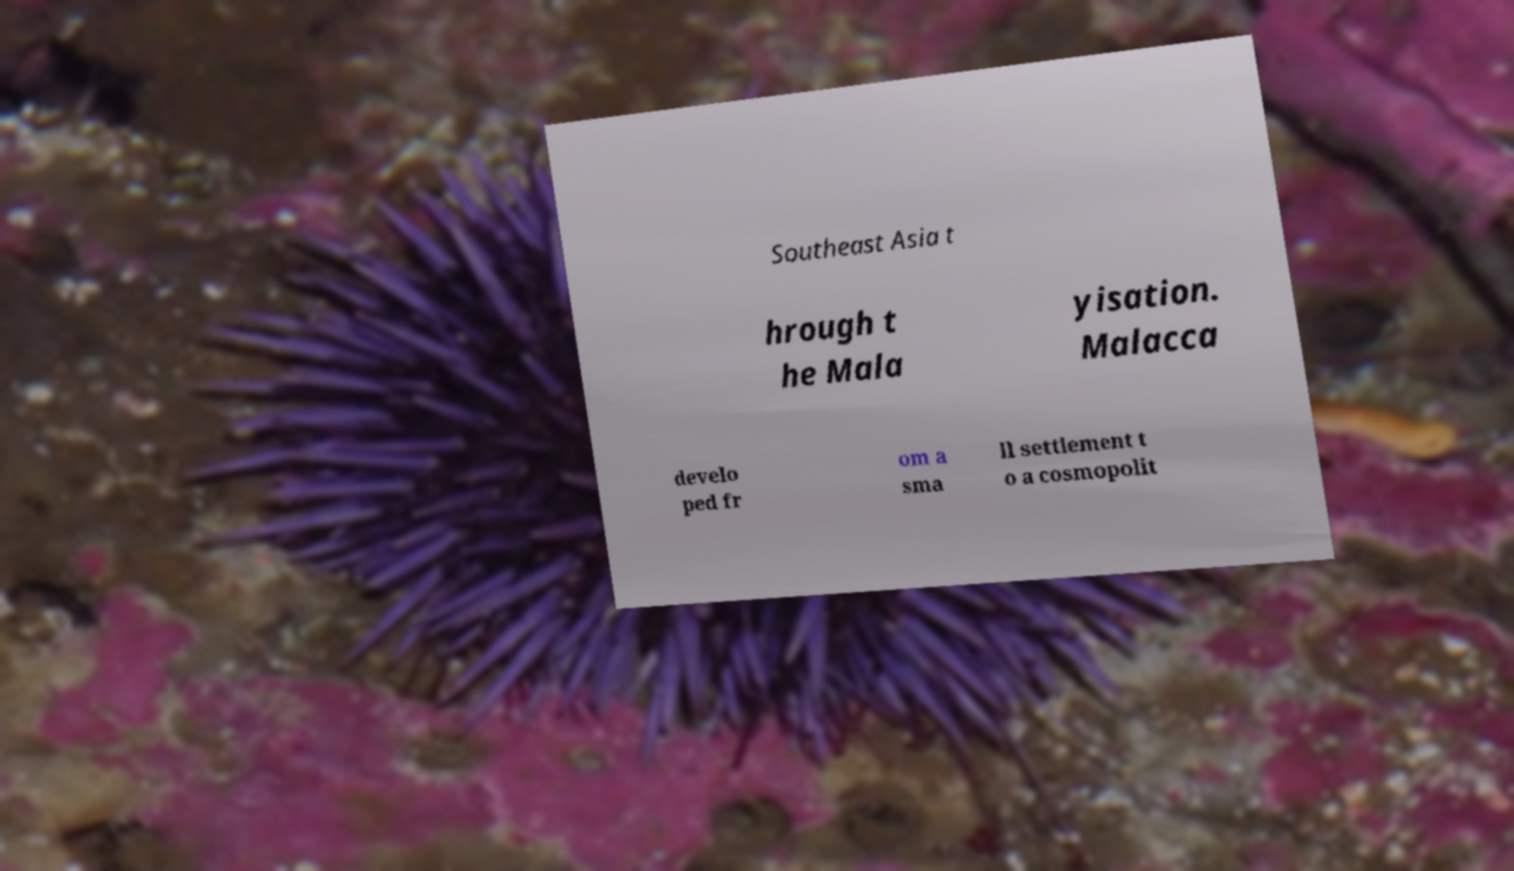Can you accurately transcribe the text from the provided image for me? Southeast Asia t hrough t he Mala yisation. Malacca develo ped fr om a sma ll settlement t o a cosmopolit 